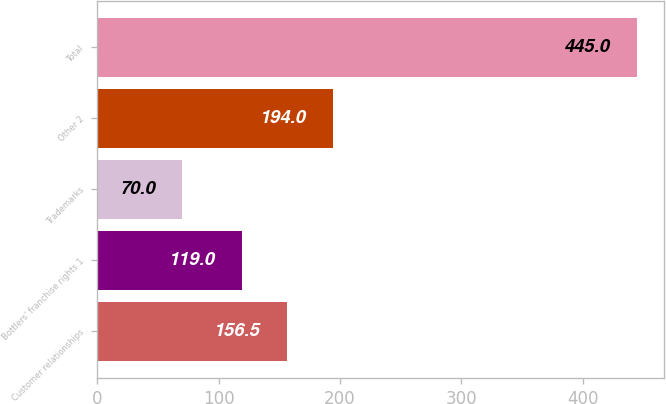Convert chart. <chart><loc_0><loc_0><loc_500><loc_500><bar_chart><fcel>Customer relationships<fcel>Bottlers' franchise rights 1<fcel>Trademarks<fcel>Other 2<fcel>Total<nl><fcel>156.5<fcel>119<fcel>70<fcel>194<fcel>445<nl></chart> 